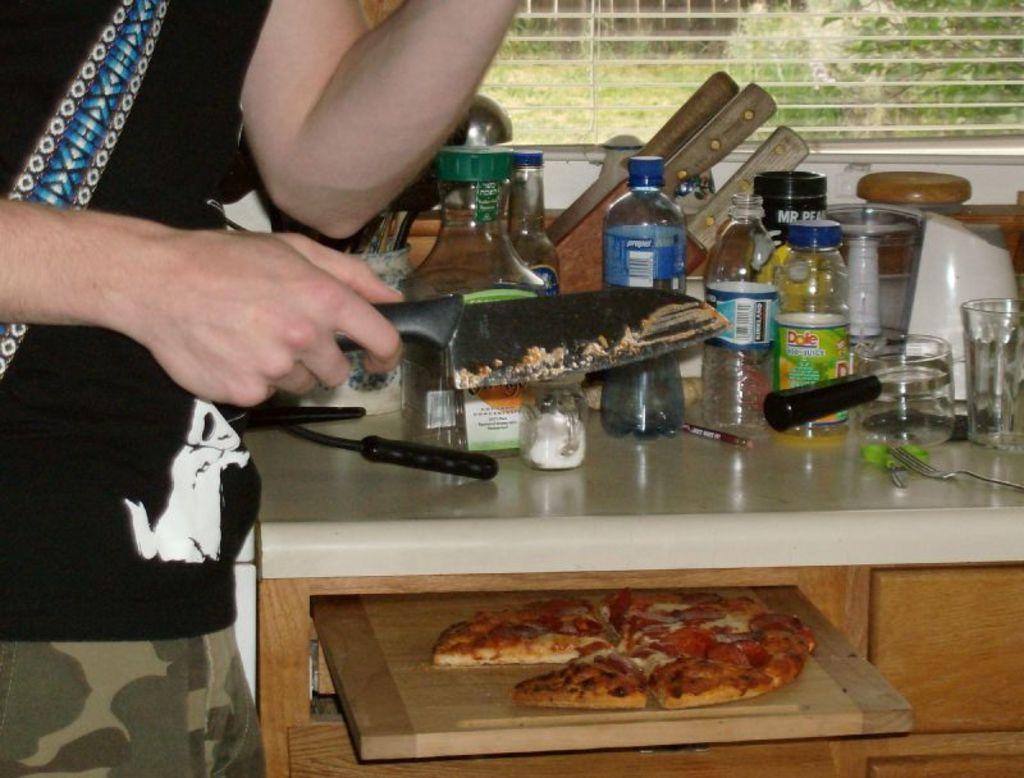Are those dole peaches in a a can?
Provide a short and direct response. Answering does not require reading text in the image. 